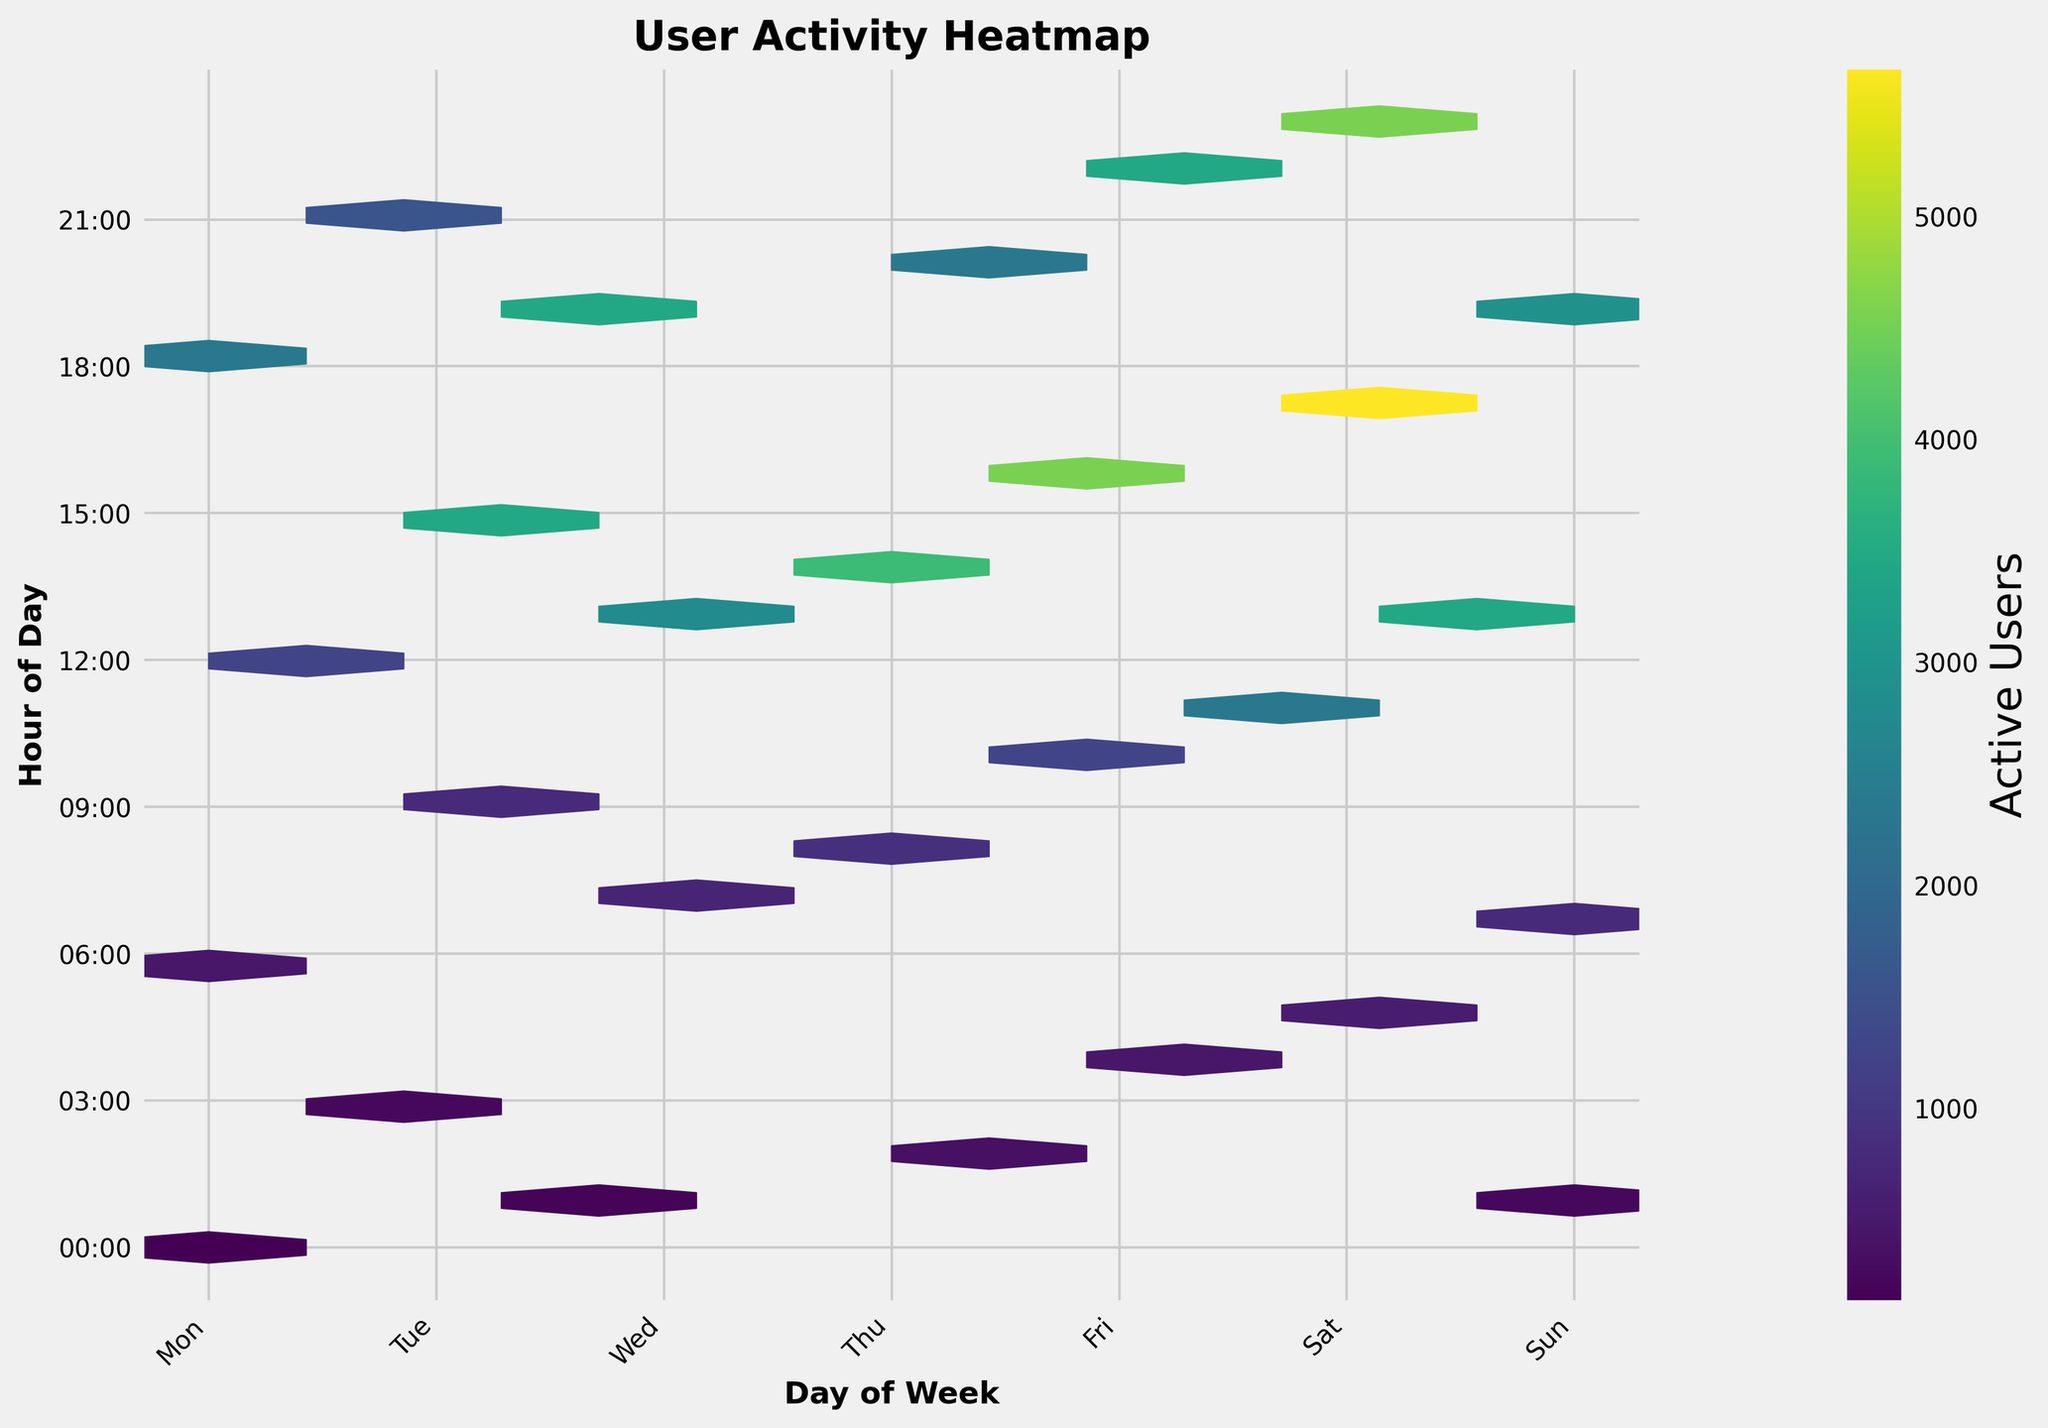What does the color bar on the right side of the figure represent? The color bar on the right side of the figure indicates the number of active users in the hexagonal bins. The shading ranges from lighter to darker, representing fewer to more active users.
Answer: Number of active users How is the "Day of Week" represented in the figure? The days of the week are represented along the x-axis with labels ranging from Monday to Sunday. Each day is indicated at specific positions on the x-axis with ticks labeled as 'Mon', 'Tue', 'Wed', 'Thu', 'Fri', 'Sat', and 'Sun'.
Answer: X-axis labels At what time does user activity peak on Tuesday? User activity on Tuesday peaks at 3 PM (15:00) as indicated by the darkest hexagonal bin on the y-axis corresponding to 15:00.
Answer: 15:00 Which day shows the least activity around midnight (00:00)? By examining the plot, Monday around midnight (00:00) has the least activity when compared across other days. The hexagonal bin is relatively lighter at this time on Monday.
Answer: Monday Between Wednesday at 1 AM and Sunday at 1 AM, which day has more activity? Observing the hexagonal bins, Sunday at 1 AM has more activity when compared to Wednesday at 1 AM. The bin on Sunday is visibly darker.
Answer: Sunday During what time slot do weekends (Saturday and Sunday) have the highest user activity? On weekends, the highest activity occurs around 5 PM to 7 PM on Saturday and 1 PM (13:00) on Sunday, with respective dark and mid-dark colored bins.
Answer: Around 5 PM to 7 PM on Saturday and 1 PM on Sunday Which weekday tends to have the most consistent user engagement throughout the day? Friday displays the most consistent user engagement with more even dispersion of darker hexagonal bins throughout the day, indicating steady active users from morning to late night.
Answer: Friday Comparing Monday at 18:00 and Friday at 16:00, which hour has a higher number of active users? Monday at 18:00 has fewer active users compared to Friday at 16:00. This is reflected by a relatively lighter hexagonal bin at Monday 18:00 versus a darker one at Friday 16:00.
Answer: Friday at 16:00 What is the general trend of user activity throughout the days in terms of periods of low and high activity? The general trend indicates a higher user activity in the afternoons to evenings between 12:00 PM to 7 PM on most days, with relatively lower activity during early mornings before 6 AM and later at night post 9 PM.
Answer: Higher in afternoons, lower in early mornings and late nights 